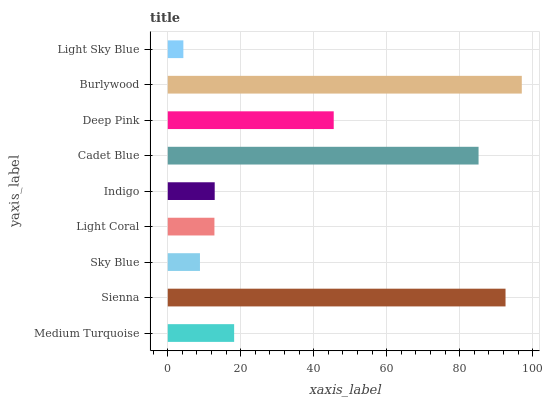Is Light Sky Blue the minimum?
Answer yes or no. Yes. Is Burlywood the maximum?
Answer yes or no. Yes. Is Sienna the minimum?
Answer yes or no. No. Is Sienna the maximum?
Answer yes or no. No. Is Sienna greater than Medium Turquoise?
Answer yes or no. Yes. Is Medium Turquoise less than Sienna?
Answer yes or no. Yes. Is Medium Turquoise greater than Sienna?
Answer yes or no. No. Is Sienna less than Medium Turquoise?
Answer yes or no. No. Is Medium Turquoise the high median?
Answer yes or no. Yes. Is Medium Turquoise the low median?
Answer yes or no. Yes. Is Indigo the high median?
Answer yes or no. No. Is Burlywood the low median?
Answer yes or no. No. 